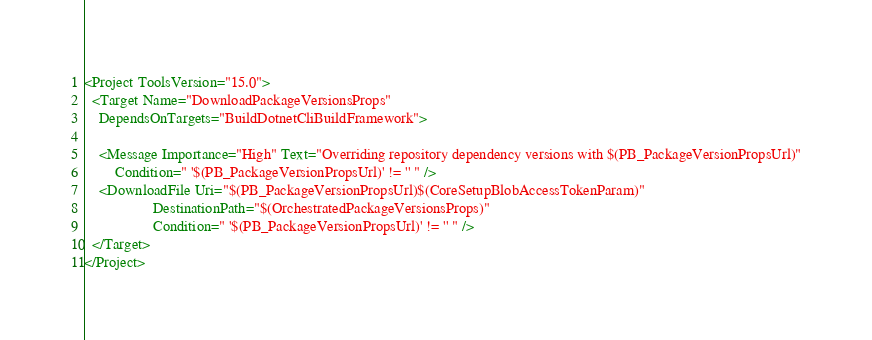<code> <loc_0><loc_0><loc_500><loc_500><_XML_><Project ToolsVersion="15.0">
  <Target Name="DownloadPackageVersionsProps"
    DependsOnTargets="BuildDotnetCliBuildFramework">

    <Message Importance="High" Text="Overriding repository dependency versions with $(PB_PackageVersionPropsUrl)"
        Condition=" '$(PB_PackageVersionPropsUrl)' != '' " />
    <DownloadFile Uri="$(PB_PackageVersionPropsUrl)$(CoreSetupBlobAccessTokenParam)"
                  DestinationPath="$(OrchestratedPackageVersionsProps)"
                  Condition=" '$(PB_PackageVersionPropsUrl)' != '' " />
  </Target>
</Project>
</code> 